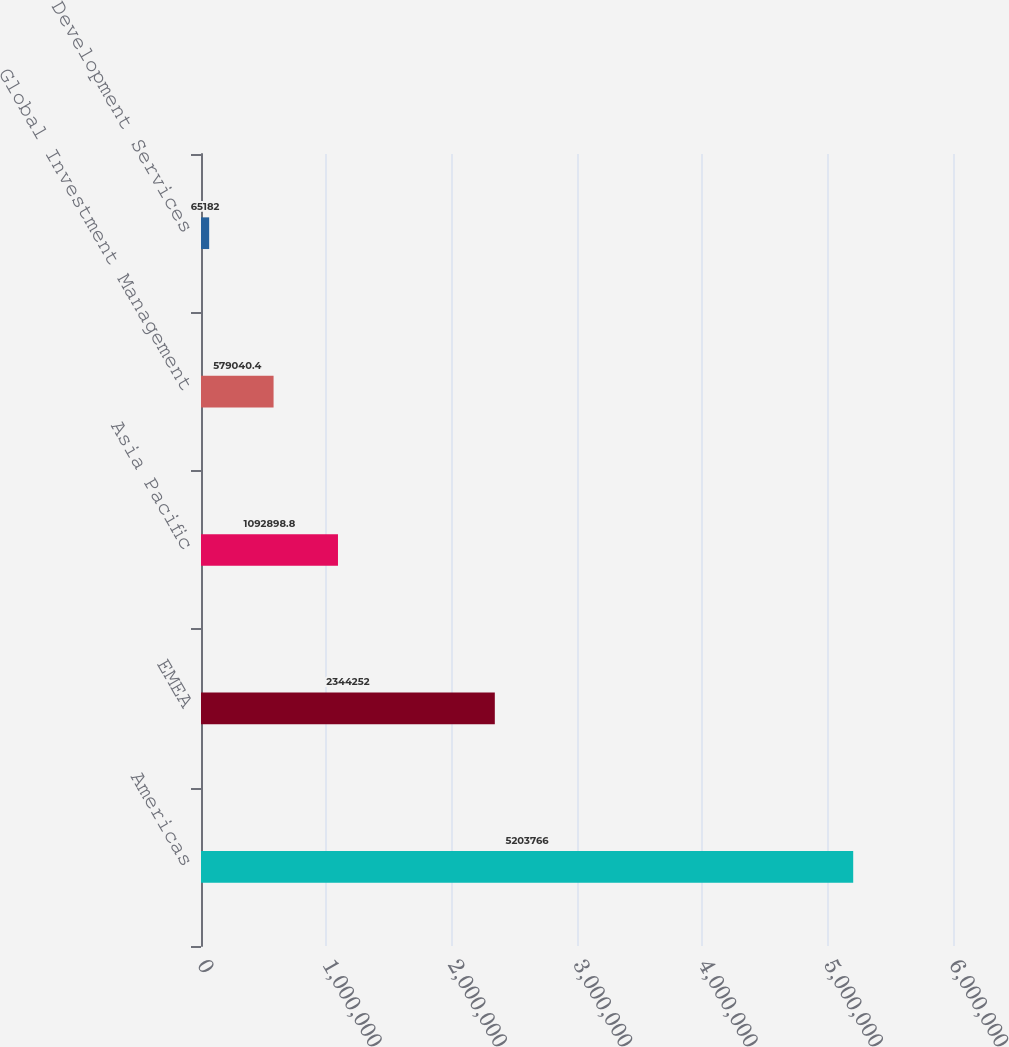<chart> <loc_0><loc_0><loc_500><loc_500><bar_chart><fcel>Americas<fcel>EMEA<fcel>Asia Pacific<fcel>Global Investment Management<fcel>Development Services<nl><fcel>5.20377e+06<fcel>2.34425e+06<fcel>1.0929e+06<fcel>579040<fcel>65182<nl></chart> 